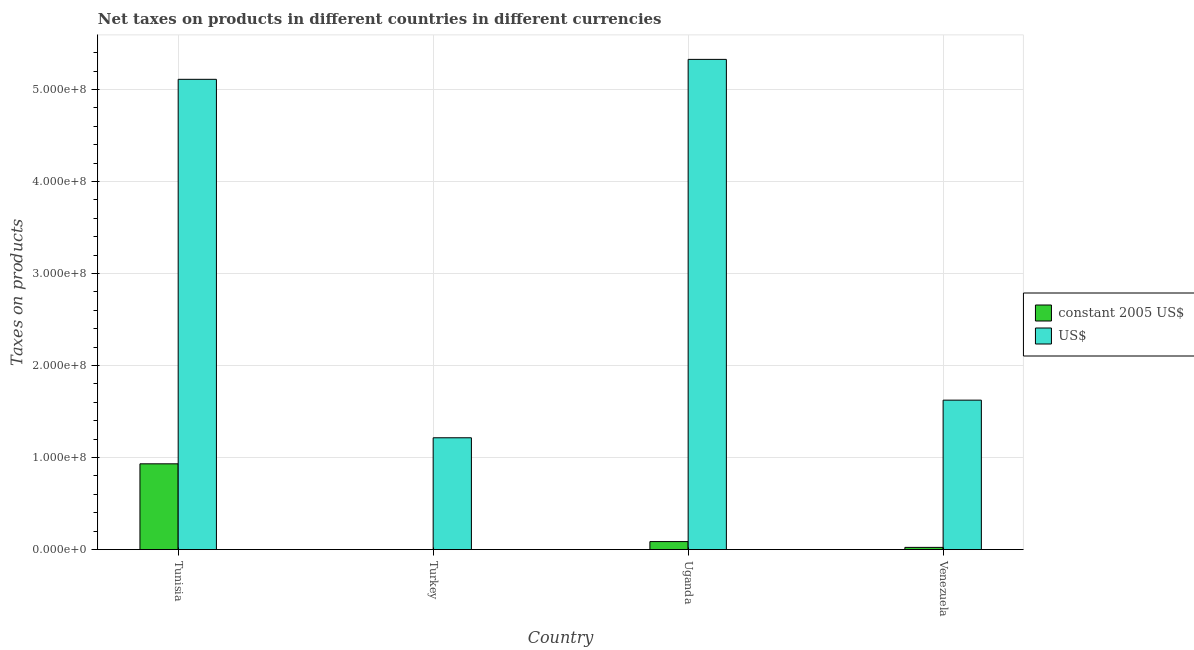Are the number of bars per tick equal to the number of legend labels?
Keep it short and to the point. Yes. How many bars are there on the 2nd tick from the left?
Offer a very short reply. 2. How many bars are there on the 3rd tick from the right?
Offer a very short reply. 2. What is the label of the 4th group of bars from the left?
Provide a short and direct response. Venezuela. What is the net taxes in us$ in Venezuela?
Provide a short and direct response. 1.62e+08. Across all countries, what is the maximum net taxes in constant 2005 us$?
Make the answer very short. 9.32e+07. Across all countries, what is the minimum net taxes in constant 2005 us$?
Ensure brevity in your answer.  4600. In which country was the net taxes in us$ maximum?
Offer a terse response. Uganda. In which country was the net taxes in constant 2005 us$ minimum?
Give a very brief answer. Turkey. What is the total net taxes in us$ in the graph?
Make the answer very short. 1.33e+09. What is the difference between the net taxes in us$ in Tunisia and that in Turkey?
Offer a terse response. 3.90e+08. What is the difference between the net taxes in us$ in Venezuela and the net taxes in constant 2005 us$ in Turkey?
Make the answer very short. 1.62e+08. What is the average net taxes in constant 2005 us$ per country?
Provide a short and direct response. 2.61e+07. What is the difference between the net taxes in constant 2005 us$ and net taxes in us$ in Uganda?
Ensure brevity in your answer.  -5.24e+08. In how many countries, is the net taxes in constant 2005 us$ greater than 420000000 units?
Your answer should be very brief. 0. What is the ratio of the net taxes in us$ in Turkey to that in Uganda?
Provide a short and direct response. 0.23. What is the difference between the highest and the second highest net taxes in us$?
Your response must be concise. 2.17e+07. What is the difference between the highest and the lowest net taxes in us$?
Your response must be concise. 4.11e+08. Is the sum of the net taxes in us$ in Tunisia and Uganda greater than the maximum net taxes in constant 2005 us$ across all countries?
Provide a short and direct response. Yes. What does the 1st bar from the left in Turkey represents?
Provide a succinct answer. Constant 2005 us$. What does the 1st bar from the right in Turkey represents?
Offer a terse response. US$. How many bars are there?
Ensure brevity in your answer.  8. Are all the bars in the graph horizontal?
Offer a terse response. No. Does the graph contain any zero values?
Keep it short and to the point. No. Where does the legend appear in the graph?
Ensure brevity in your answer.  Center right. How many legend labels are there?
Ensure brevity in your answer.  2. What is the title of the graph?
Offer a terse response. Net taxes on products in different countries in different currencies. Does "Non-solid fuel" appear as one of the legend labels in the graph?
Your answer should be very brief. No. What is the label or title of the Y-axis?
Your response must be concise. Taxes on products. What is the Taxes on products of constant 2005 US$ in Tunisia?
Your answer should be compact. 9.32e+07. What is the Taxes on products in US$ in Tunisia?
Give a very brief answer. 5.11e+08. What is the Taxes on products of constant 2005 US$ in Turkey?
Give a very brief answer. 4600. What is the Taxes on products of US$ in Turkey?
Make the answer very short. 1.22e+08. What is the Taxes on products in constant 2005 US$ in Uganda?
Make the answer very short. 8.68e+06. What is the Taxes on products of US$ in Uganda?
Your answer should be very brief. 5.33e+08. What is the Taxes on products of constant 2005 US$ in Venezuela?
Provide a short and direct response. 2.37e+06. What is the Taxes on products of US$ in Venezuela?
Give a very brief answer. 1.62e+08. Across all countries, what is the maximum Taxes on products of constant 2005 US$?
Ensure brevity in your answer.  9.32e+07. Across all countries, what is the maximum Taxes on products of US$?
Provide a succinct answer. 5.33e+08. Across all countries, what is the minimum Taxes on products of constant 2005 US$?
Offer a terse response. 4600. Across all countries, what is the minimum Taxes on products of US$?
Give a very brief answer. 1.22e+08. What is the total Taxes on products of constant 2005 US$ in the graph?
Your answer should be compact. 1.04e+08. What is the total Taxes on products of US$ in the graph?
Offer a very short reply. 1.33e+09. What is the difference between the Taxes on products in constant 2005 US$ in Tunisia and that in Turkey?
Provide a succinct answer. 9.32e+07. What is the difference between the Taxes on products in US$ in Tunisia and that in Turkey?
Keep it short and to the point. 3.90e+08. What is the difference between the Taxes on products of constant 2005 US$ in Tunisia and that in Uganda?
Give a very brief answer. 8.45e+07. What is the difference between the Taxes on products in US$ in Tunisia and that in Uganda?
Make the answer very short. -2.17e+07. What is the difference between the Taxes on products in constant 2005 US$ in Tunisia and that in Venezuela?
Provide a succinct answer. 9.08e+07. What is the difference between the Taxes on products of US$ in Tunisia and that in Venezuela?
Keep it short and to the point. 3.49e+08. What is the difference between the Taxes on products in constant 2005 US$ in Turkey and that in Uganda?
Provide a short and direct response. -8.68e+06. What is the difference between the Taxes on products in US$ in Turkey and that in Uganda?
Make the answer very short. -4.11e+08. What is the difference between the Taxes on products in constant 2005 US$ in Turkey and that in Venezuela?
Give a very brief answer. -2.37e+06. What is the difference between the Taxes on products of US$ in Turkey and that in Venezuela?
Keep it short and to the point. -4.09e+07. What is the difference between the Taxes on products of constant 2005 US$ in Uganda and that in Venezuela?
Offer a very short reply. 6.31e+06. What is the difference between the Taxes on products in US$ in Uganda and that in Venezuela?
Keep it short and to the point. 3.70e+08. What is the difference between the Taxes on products in constant 2005 US$ in Tunisia and the Taxes on products in US$ in Turkey?
Your answer should be very brief. -2.83e+07. What is the difference between the Taxes on products of constant 2005 US$ in Tunisia and the Taxes on products of US$ in Uganda?
Your response must be concise. -4.40e+08. What is the difference between the Taxes on products in constant 2005 US$ in Tunisia and the Taxes on products in US$ in Venezuela?
Your response must be concise. -6.92e+07. What is the difference between the Taxes on products in constant 2005 US$ in Turkey and the Taxes on products in US$ in Uganda?
Provide a succinct answer. -5.33e+08. What is the difference between the Taxes on products in constant 2005 US$ in Turkey and the Taxes on products in US$ in Venezuela?
Your answer should be very brief. -1.62e+08. What is the difference between the Taxes on products in constant 2005 US$ in Uganda and the Taxes on products in US$ in Venezuela?
Provide a succinct answer. -1.54e+08. What is the average Taxes on products of constant 2005 US$ per country?
Give a very brief answer. 2.61e+07. What is the average Taxes on products in US$ per country?
Offer a terse response. 3.32e+08. What is the difference between the Taxes on products of constant 2005 US$ and Taxes on products of US$ in Tunisia?
Provide a short and direct response. -4.18e+08. What is the difference between the Taxes on products of constant 2005 US$ and Taxes on products of US$ in Turkey?
Your answer should be very brief. -1.22e+08. What is the difference between the Taxes on products in constant 2005 US$ and Taxes on products in US$ in Uganda?
Provide a succinct answer. -5.24e+08. What is the difference between the Taxes on products of constant 2005 US$ and Taxes on products of US$ in Venezuela?
Ensure brevity in your answer.  -1.60e+08. What is the ratio of the Taxes on products in constant 2005 US$ in Tunisia to that in Turkey?
Offer a very short reply. 2.03e+04. What is the ratio of the Taxes on products of US$ in Tunisia to that in Turkey?
Provide a short and direct response. 4.21. What is the ratio of the Taxes on products in constant 2005 US$ in Tunisia to that in Uganda?
Provide a short and direct response. 10.74. What is the ratio of the Taxes on products in US$ in Tunisia to that in Uganda?
Offer a terse response. 0.96. What is the ratio of the Taxes on products of constant 2005 US$ in Tunisia to that in Venezuela?
Provide a succinct answer. 39.31. What is the ratio of the Taxes on products of US$ in Tunisia to that in Venezuela?
Offer a terse response. 3.15. What is the ratio of the Taxes on products of US$ in Turkey to that in Uganda?
Offer a very short reply. 0.23. What is the ratio of the Taxes on products in constant 2005 US$ in Turkey to that in Venezuela?
Provide a succinct answer. 0. What is the ratio of the Taxes on products of US$ in Turkey to that in Venezuela?
Your answer should be very brief. 0.75. What is the ratio of the Taxes on products of constant 2005 US$ in Uganda to that in Venezuela?
Keep it short and to the point. 3.66. What is the ratio of the Taxes on products of US$ in Uganda to that in Venezuela?
Offer a very short reply. 3.28. What is the difference between the highest and the second highest Taxes on products in constant 2005 US$?
Your answer should be very brief. 8.45e+07. What is the difference between the highest and the second highest Taxes on products of US$?
Keep it short and to the point. 2.17e+07. What is the difference between the highest and the lowest Taxes on products of constant 2005 US$?
Provide a short and direct response. 9.32e+07. What is the difference between the highest and the lowest Taxes on products of US$?
Provide a short and direct response. 4.11e+08. 